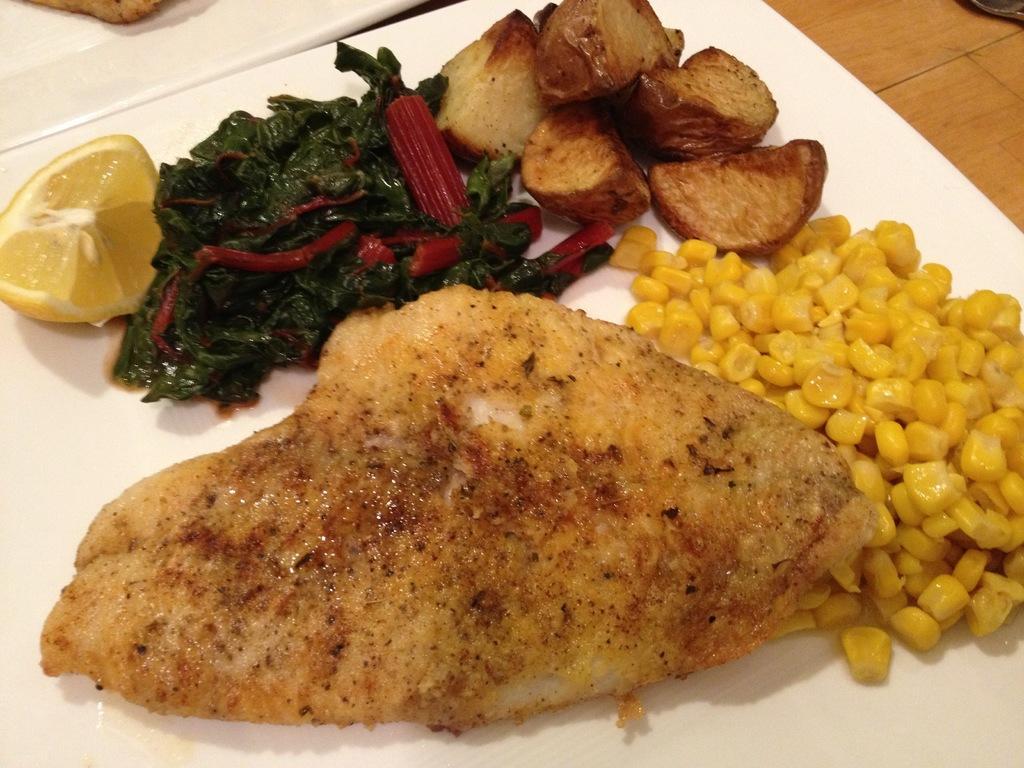How would you summarize this image in a sentence or two? This is a zoomed in picture. In the foreground there is a white color palette containing baby corns, sliced lemon and some food items. In the background we can see another white color platter and we can see the wooden table. 